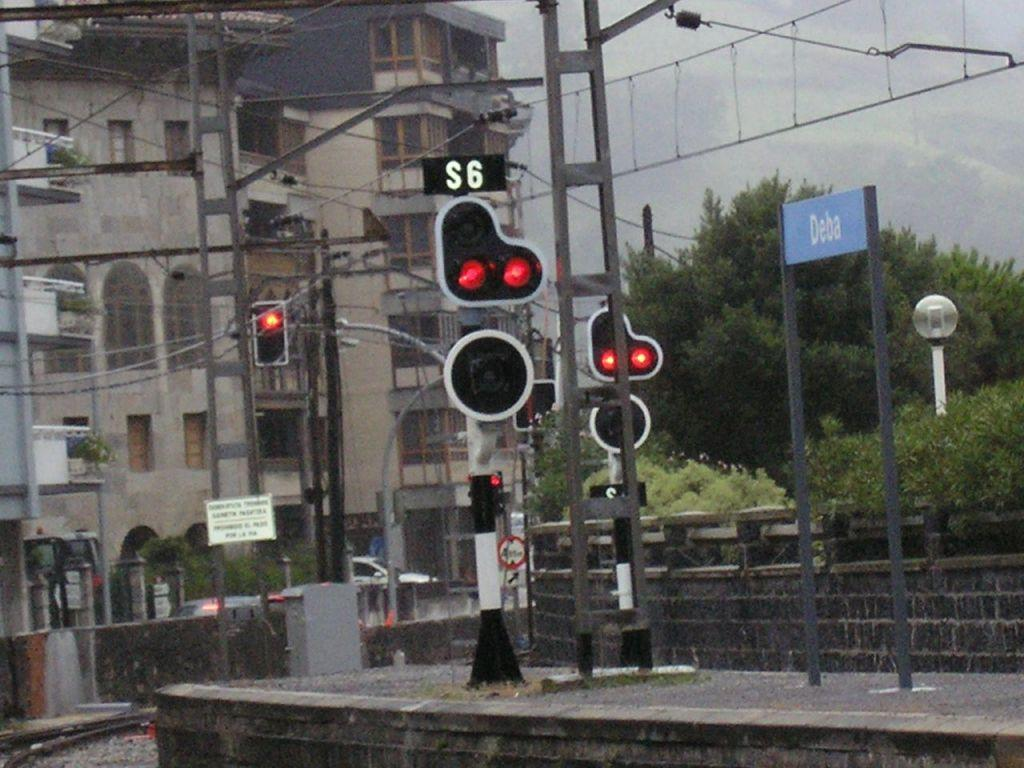<image>
Provide a brief description of the given image. A group of street lights are on with one having S6 above it and a blue sign saying Deba next to them. 